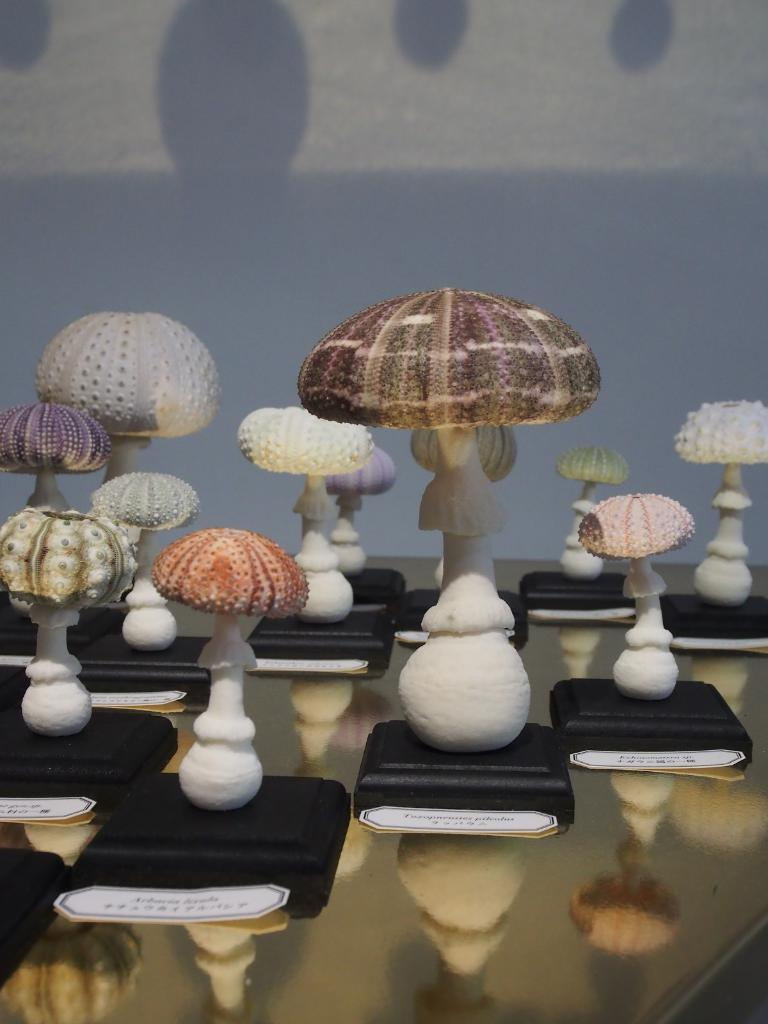What type of objects are present on the table in the image? There are ceramic lamps of various sizes on the table in the image. Can you describe the lamps in more detail? The lamps are of various sizes. What is visible in the background of the image? There is a wall visible in the image. What type of zephyr can be seen blowing through the lamps in the image? There is no zephyr present in the image; it is a still image. What type of business is being conducted in the image? There is no indication of any business being conducted in the image. 